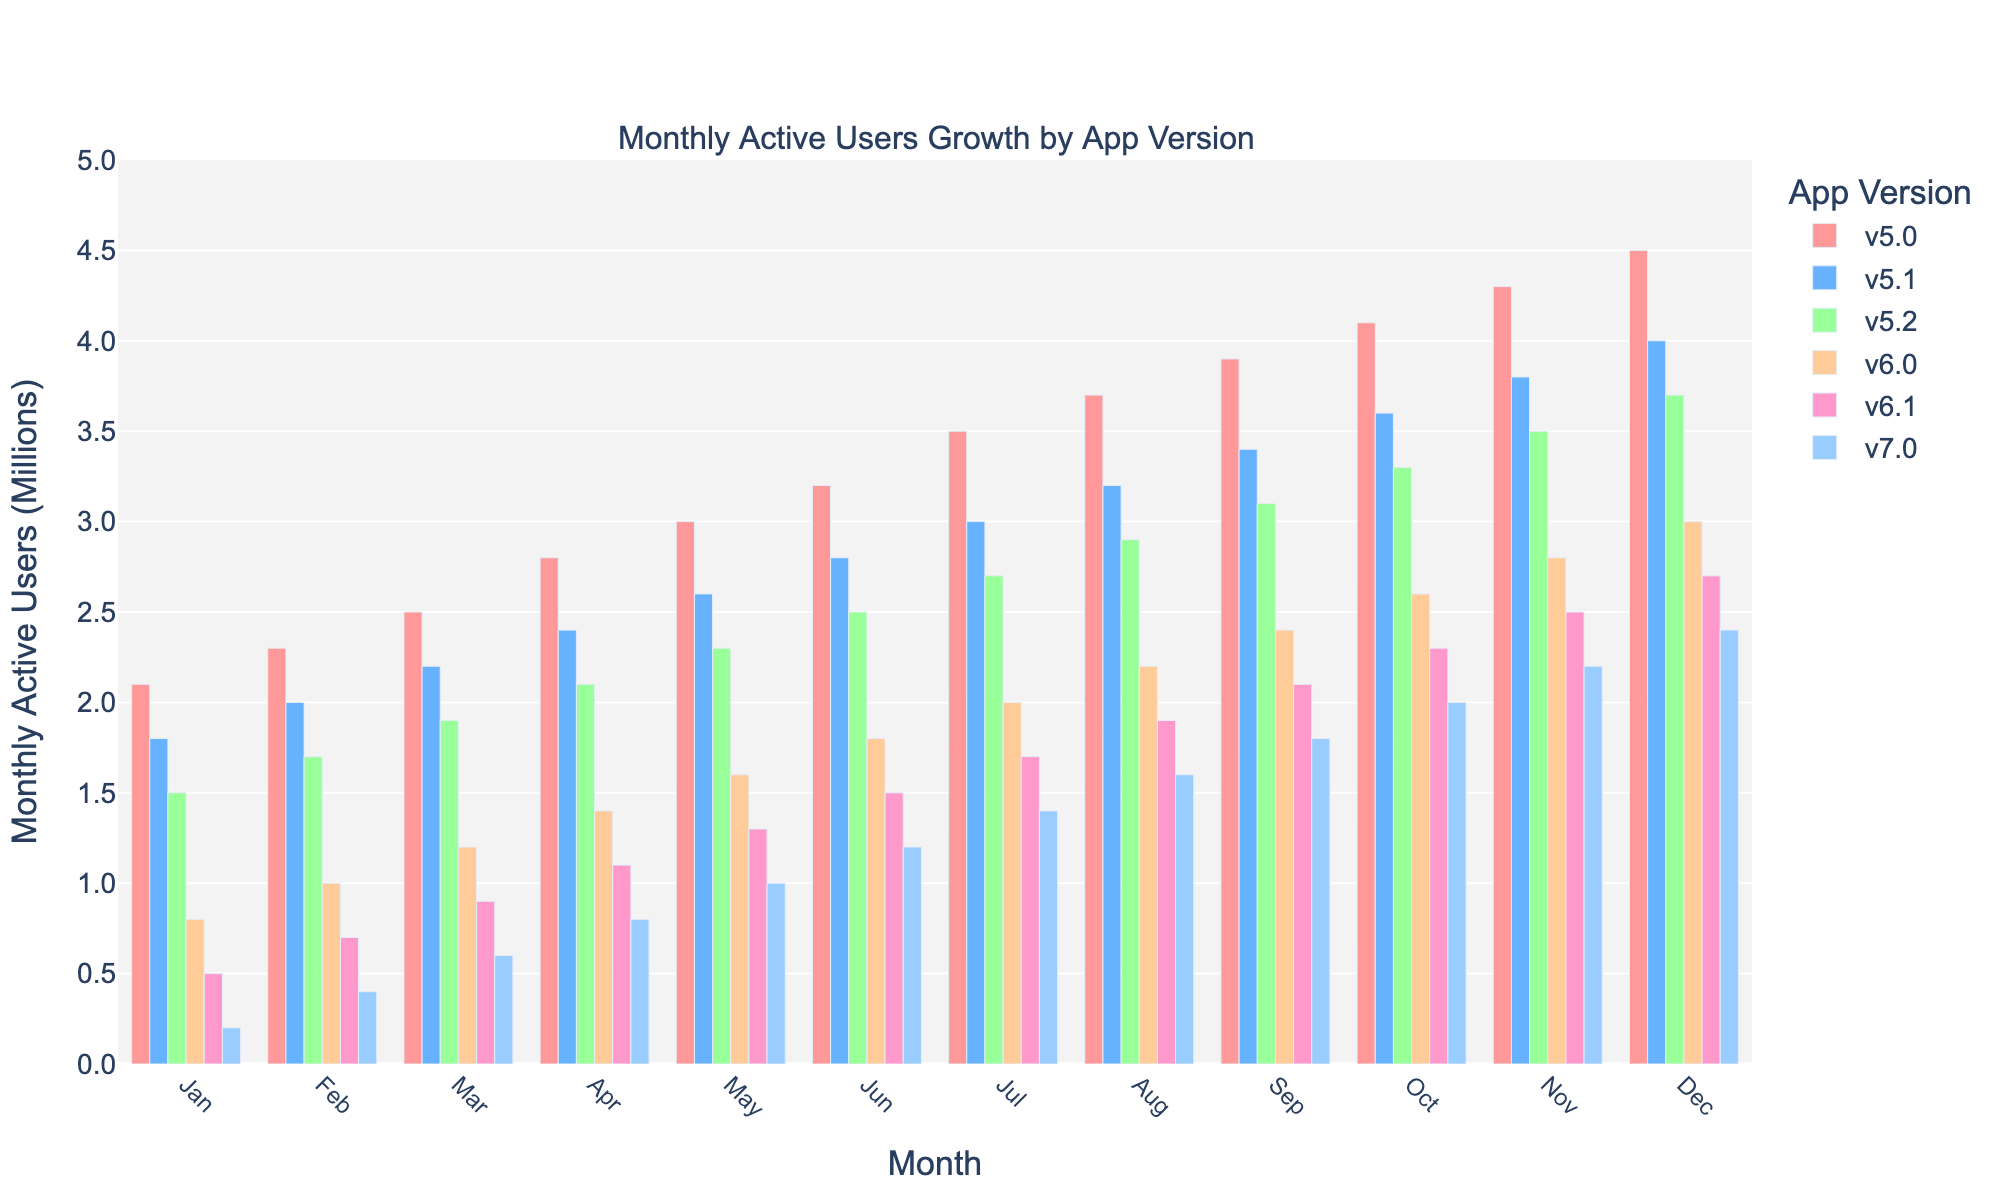What was the growth in monthly active users for version 5.0 from January to December? To determine the growth, we subtract the number of users in January (2.1M) from the number of users in December (4.5M). This gives us 4.5M - 2.1M = 2.4M.
Answer: 2.4M Which app version had the highest number of active users in December? By comparing the user counts in December, version 5.0 has the highest users with 4.5M.
Answer: v5.0 How do the monthly active users of version 6.0 in June compare to those of version 6.1 in March? In June, v6.0 had 1.8M users. In March, v6.1 had 0.9M users. Since 1.8M > 0.9M, version 6.0 in June had more users.
Answer: 6.0 in June What is the average number of monthly active users for version 7.0 across the year? Sum the users for v7.0: (0.2 + 0.4 + 0.6 + 0.8 + 1.0 + 1.2 + 1.4 + 1.6 + 1.8 + 2.0 + 2.2 + 2.4) = 16.6M. There are 12 months, so 16.6M/12 = 1.38M.
Answer: 1.38M 